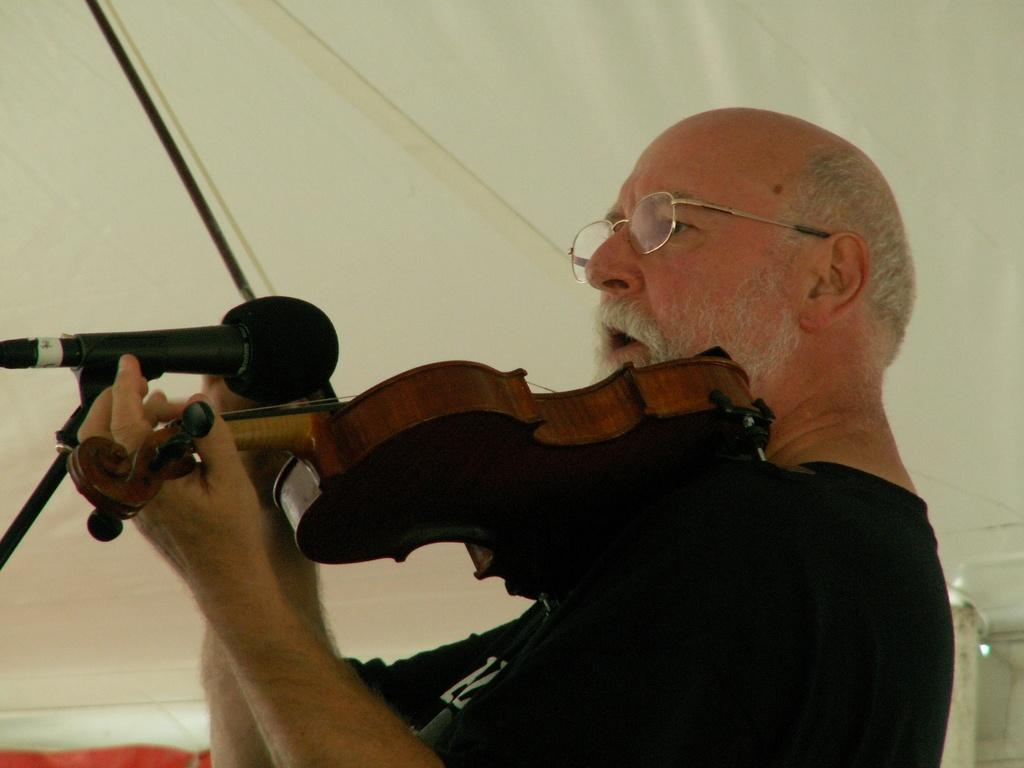What is the man in the image doing? The man is playing a guitar in the image. What can be seen on the man's face? The man is wearing spectacles and has his mouth open. What is the man wearing on his upper body? The man is wearing a T-shirt. What object is present in the image that is typically used for amplifying sound? There is a microphone in the image. What type of linen is being used to cover the guitar in the image? There is no linen present in the image, and the guitar is not covered. Who is the manager of the band in the image? There is no indication of a band or a manager in the image. 